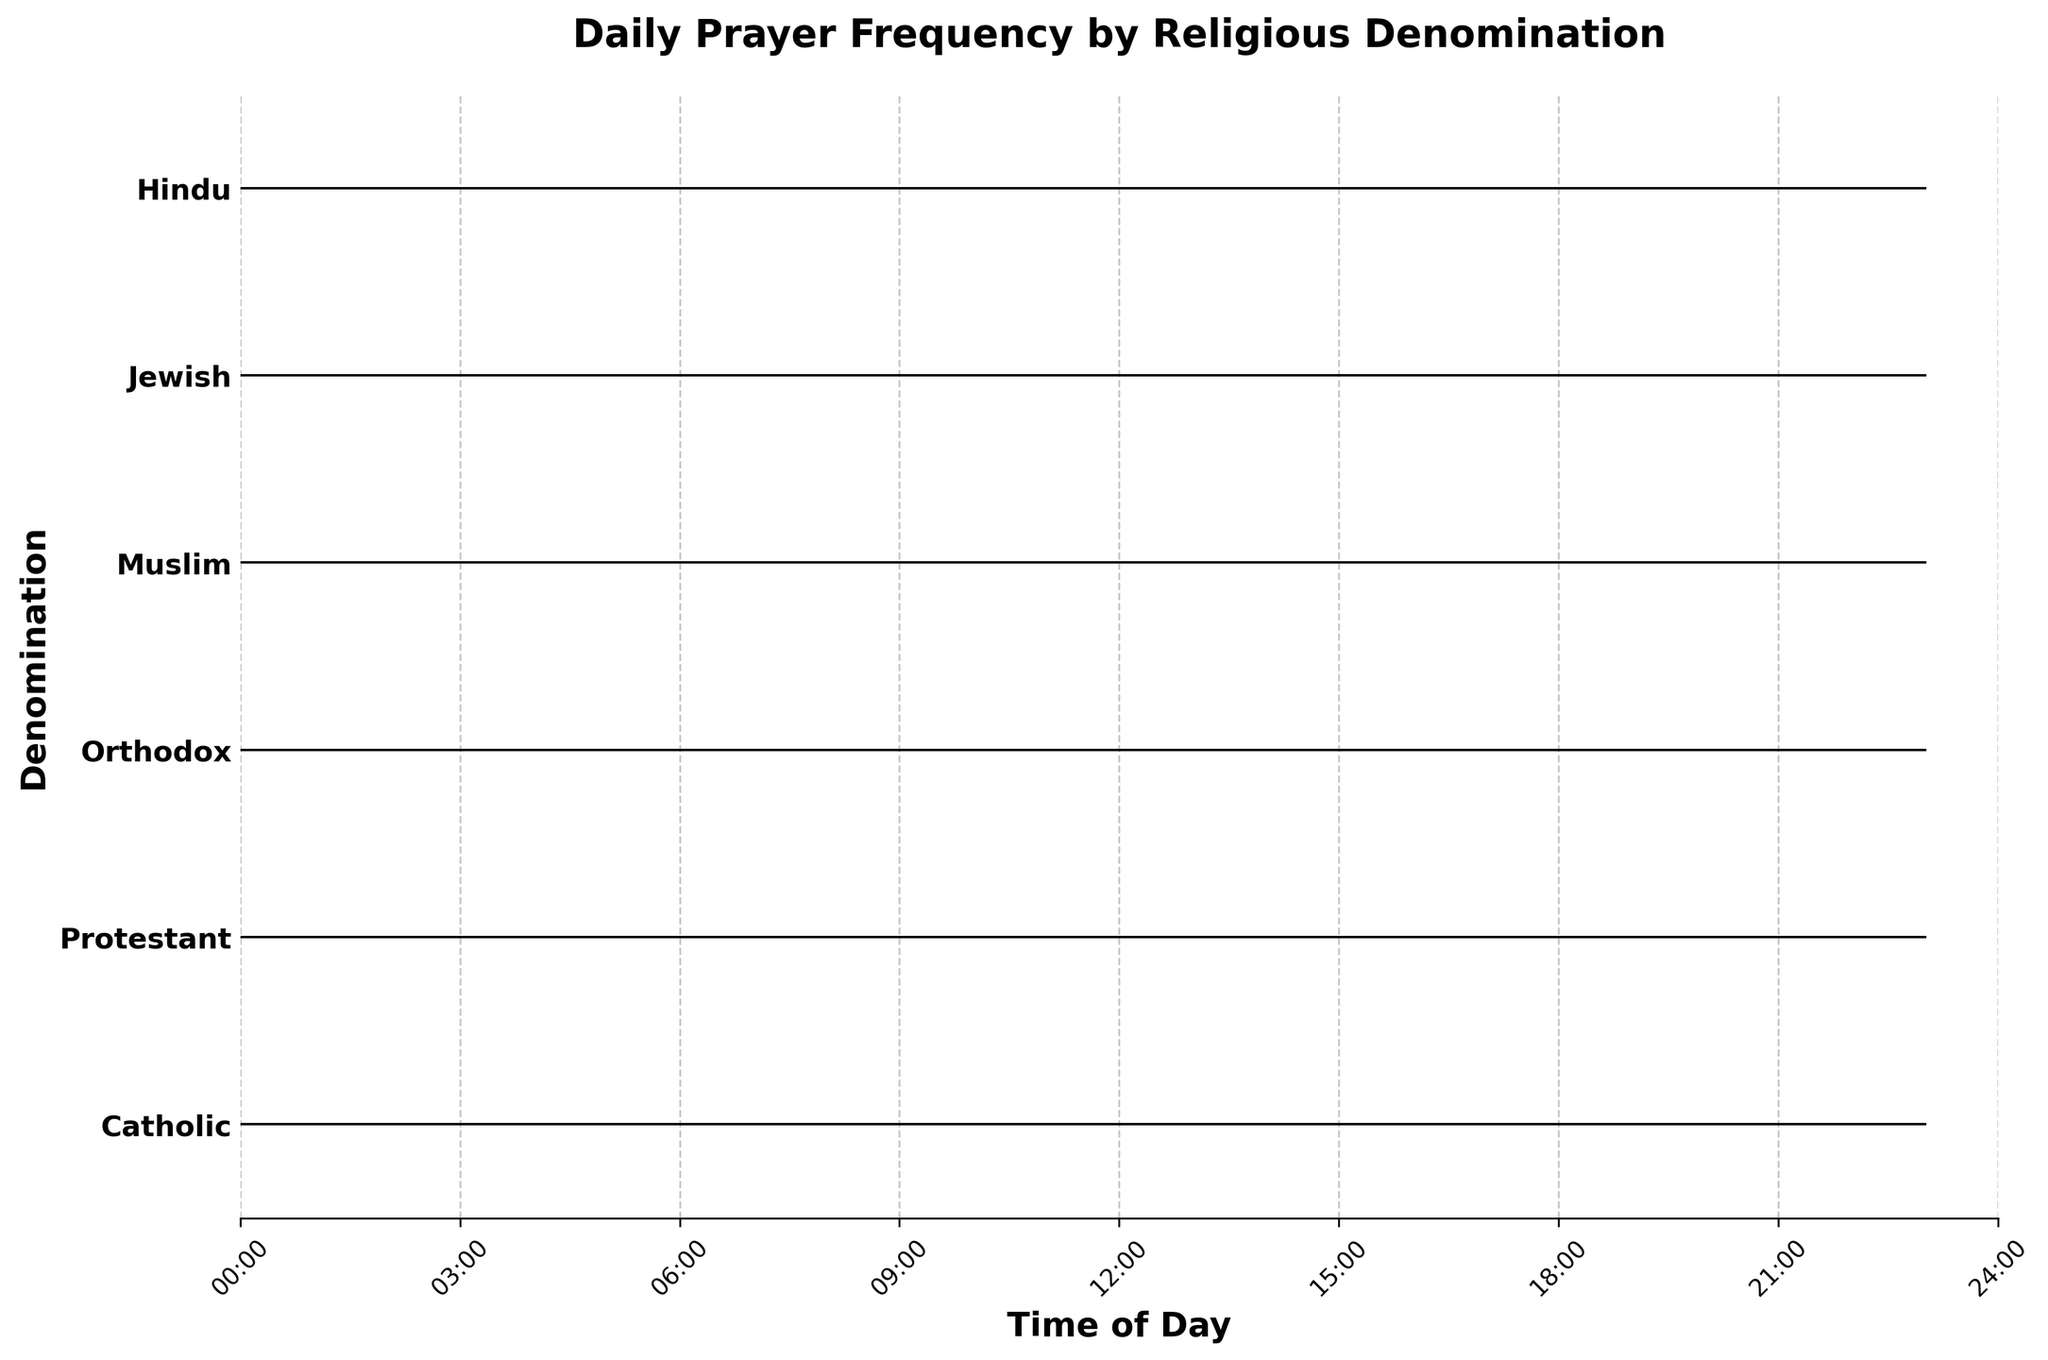What's the title of the plot? The title of the plot is written at the top, indicating the subject of the visualized data.
Answer: Daily Prayer Frequency by Religious Denomination What does the y-axis represent? The y-axis lists the different religious denominations, indicating which denomination's prayer frequency is being displayed.
Answer: Religious denominations How often do Catholics pray at 18:00? By looking at the fill area and the corresponding y-label for Catholics at the 18:00 mark on the x-axis, you can see the prayer frequency value.
Answer: 0.6 Which denomination has the highest prayer frequency at 6:00? Examine the fill areas for all denominations at the 6:00 mark on the x-axis. The Orthodox denomination has the highest value.
Answer: Orthodox At what time do Muslims show the highest prayer frequency? Look along the x-axis for Muslim peaks; the highest peak is at 12:00.
Answer: 12:00 How does the prayer frequency of Jews at 18:00 compare to that of Catholics at the same time? Check the heights of the filled areas for Jews and Catholics at 18:00. Jews have a higher frequency (0.7 vs. 0.6 for Catholics).
Answer: Jews: 0.7, Catholics: 0.6 Which denomination shows a significant rise in prayer frequency between 0:00 and 6:00? Observing the lines and fill between 0:00 and 6:00, the Muslim denomination shows a significant increase.
Answer: Muslim At what times do Hindus have their prayer frequencies above 0.6? Identify the points on the timeline where Hindu prayer frequency exceeds 0.6. It's at 6:00 and 18:00.
Answer: 6:00 and 18:00 What is the combined prayer frequency of Protestants at 0:00 and 12:00? Locate and add the prayer frequencies for Protestants at 0:00 (0.1) and 12:00 (0.5).
Answer: 0.6 